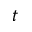<formula> <loc_0><loc_0><loc_500><loc_500>t</formula> 